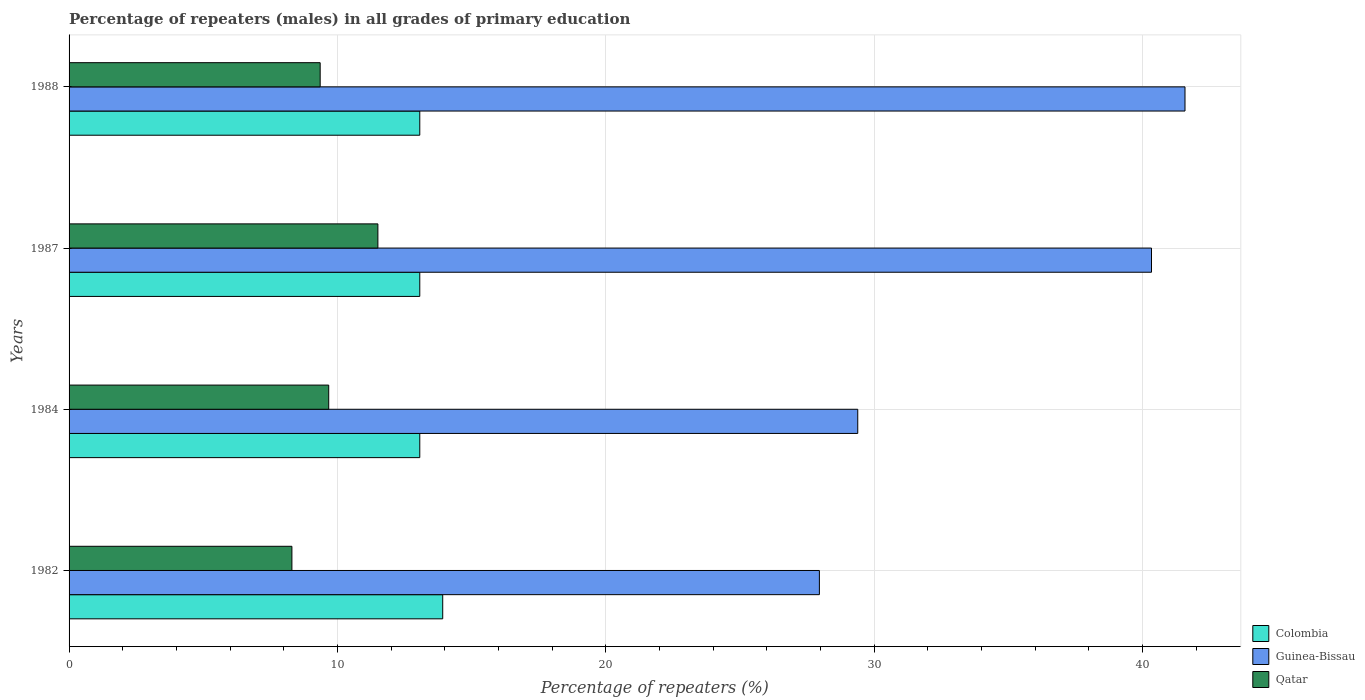What is the label of the 1st group of bars from the top?
Offer a very short reply. 1988. In how many cases, is the number of bars for a given year not equal to the number of legend labels?
Offer a very short reply. 0. What is the percentage of repeaters (males) in Qatar in 1988?
Offer a terse response. 9.36. Across all years, what is the maximum percentage of repeaters (males) in Qatar?
Keep it short and to the point. 11.51. Across all years, what is the minimum percentage of repeaters (males) in Qatar?
Provide a succinct answer. 8.3. In which year was the percentage of repeaters (males) in Colombia maximum?
Provide a short and direct response. 1982. What is the total percentage of repeaters (males) in Colombia in the graph?
Offer a very short reply. 53.13. What is the difference between the percentage of repeaters (males) in Qatar in 1987 and that in 1988?
Your answer should be very brief. 2.15. What is the difference between the percentage of repeaters (males) in Colombia in 1987 and the percentage of repeaters (males) in Qatar in 1988?
Make the answer very short. 3.71. What is the average percentage of repeaters (males) in Guinea-Bissau per year?
Your answer should be compact. 34.81. In the year 1982, what is the difference between the percentage of repeaters (males) in Qatar and percentage of repeaters (males) in Colombia?
Provide a short and direct response. -5.62. What is the ratio of the percentage of repeaters (males) in Colombia in 1984 to that in 1987?
Make the answer very short. 1. Is the difference between the percentage of repeaters (males) in Qatar in 1984 and 1988 greater than the difference between the percentage of repeaters (males) in Colombia in 1984 and 1988?
Ensure brevity in your answer.  Yes. What is the difference between the highest and the second highest percentage of repeaters (males) in Qatar?
Your response must be concise. 1.83. What is the difference between the highest and the lowest percentage of repeaters (males) in Colombia?
Your answer should be very brief. 0.85. In how many years, is the percentage of repeaters (males) in Guinea-Bissau greater than the average percentage of repeaters (males) in Guinea-Bissau taken over all years?
Give a very brief answer. 2. What does the 2nd bar from the top in 1984 represents?
Ensure brevity in your answer.  Guinea-Bissau. What does the 2nd bar from the bottom in 1982 represents?
Your answer should be very brief. Guinea-Bissau. Is it the case that in every year, the sum of the percentage of repeaters (males) in Colombia and percentage of repeaters (males) in Qatar is greater than the percentage of repeaters (males) in Guinea-Bissau?
Keep it short and to the point. No. Are all the bars in the graph horizontal?
Make the answer very short. Yes. What is the difference between two consecutive major ticks on the X-axis?
Provide a succinct answer. 10. Are the values on the major ticks of X-axis written in scientific E-notation?
Give a very brief answer. No. Does the graph contain any zero values?
Your response must be concise. No. How are the legend labels stacked?
Your answer should be very brief. Vertical. What is the title of the graph?
Your answer should be compact. Percentage of repeaters (males) in all grades of primary education. Does "Nigeria" appear as one of the legend labels in the graph?
Ensure brevity in your answer.  No. What is the label or title of the X-axis?
Your answer should be compact. Percentage of repeaters (%). What is the label or title of the Y-axis?
Make the answer very short. Years. What is the Percentage of repeaters (%) in Colombia in 1982?
Keep it short and to the point. 13.92. What is the Percentage of repeaters (%) in Guinea-Bissau in 1982?
Your response must be concise. 27.96. What is the Percentage of repeaters (%) of Qatar in 1982?
Your answer should be compact. 8.3. What is the Percentage of repeaters (%) in Colombia in 1984?
Your response must be concise. 13.07. What is the Percentage of repeaters (%) of Guinea-Bissau in 1984?
Provide a succinct answer. 29.39. What is the Percentage of repeaters (%) of Qatar in 1984?
Ensure brevity in your answer.  9.67. What is the Percentage of repeaters (%) of Colombia in 1987?
Offer a very short reply. 13.07. What is the Percentage of repeaters (%) of Guinea-Bissau in 1987?
Offer a terse response. 40.33. What is the Percentage of repeaters (%) in Qatar in 1987?
Your answer should be very brief. 11.51. What is the Percentage of repeaters (%) of Colombia in 1988?
Provide a short and direct response. 13.07. What is the Percentage of repeaters (%) of Guinea-Bissau in 1988?
Your answer should be very brief. 41.58. What is the Percentage of repeaters (%) in Qatar in 1988?
Provide a short and direct response. 9.36. Across all years, what is the maximum Percentage of repeaters (%) in Colombia?
Your answer should be very brief. 13.92. Across all years, what is the maximum Percentage of repeaters (%) of Guinea-Bissau?
Provide a succinct answer. 41.58. Across all years, what is the maximum Percentage of repeaters (%) in Qatar?
Your answer should be compact. 11.51. Across all years, what is the minimum Percentage of repeaters (%) of Colombia?
Make the answer very short. 13.07. Across all years, what is the minimum Percentage of repeaters (%) of Guinea-Bissau?
Keep it short and to the point. 27.96. Across all years, what is the minimum Percentage of repeaters (%) in Qatar?
Make the answer very short. 8.3. What is the total Percentage of repeaters (%) of Colombia in the graph?
Provide a short and direct response. 53.13. What is the total Percentage of repeaters (%) of Guinea-Bissau in the graph?
Make the answer very short. 139.26. What is the total Percentage of repeaters (%) in Qatar in the graph?
Offer a very short reply. 38.84. What is the difference between the Percentage of repeaters (%) of Colombia in 1982 and that in 1984?
Provide a succinct answer. 0.85. What is the difference between the Percentage of repeaters (%) in Guinea-Bissau in 1982 and that in 1984?
Ensure brevity in your answer.  -1.43. What is the difference between the Percentage of repeaters (%) in Qatar in 1982 and that in 1984?
Your answer should be very brief. -1.37. What is the difference between the Percentage of repeaters (%) of Colombia in 1982 and that in 1987?
Your answer should be very brief. 0.85. What is the difference between the Percentage of repeaters (%) in Guinea-Bissau in 1982 and that in 1987?
Provide a succinct answer. -12.38. What is the difference between the Percentage of repeaters (%) of Qatar in 1982 and that in 1987?
Your answer should be very brief. -3.2. What is the difference between the Percentage of repeaters (%) in Colombia in 1982 and that in 1988?
Keep it short and to the point. 0.85. What is the difference between the Percentage of repeaters (%) of Guinea-Bissau in 1982 and that in 1988?
Ensure brevity in your answer.  -13.62. What is the difference between the Percentage of repeaters (%) of Qatar in 1982 and that in 1988?
Offer a terse response. -1.05. What is the difference between the Percentage of repeaters (%) of Colombia in 1984 and that in 1987?
Make the answer very short. 0. What is the difference between the Percentage of repeaters (%) in Guinea-Bissau in 1984 and that in 1987?
Ensure brevity in your answer.  -10.95. What is the difference between the Percentage of repeaters (%) of Qatar in 1984 and that in 1987?
Offer a very short reply. -1.83. What is the difference between the Percentage of repeaters (%) in Guinea-Bissau in 1984 and that in 1988?
Provide a succinct answer. -12.19. What is the difference between the Percentage of repeaters (%) of Qatar in 1984 and that in 1988?
Make the answer very short. 0.32. What is the difference between the Percentage of repeaters (%) of Guinea-Bissau in 1987 and that in 1988?
Give a very brief answer. -1.25. What is the difference between the Percentage of repeaters (%) of Qatar in 1987 and that in 1988?
Give a very brief answer. 2.15. What is the difference between the Percentage of repeaters (%) of Colombia in 1982 and the Percentage of repeaters (%) of Guinea-Bissau in 1984?
Keep it short and to the point. -15.46. What is the difference between the Percentage of repeaters (%) in Colombia in 1982 and the Percentage of repeaters (%) in Qatar in 1984?
Offer a terse response. 4.25. What is the difference between the Percentage of repeaters (%) of Guinea-Bissau in 1982 and the Percentage of repeaters (%) of Qatar in 1984?
Your answer should be compact. 18.28. What is the difference between the Percentage of repeaters (%) of Colombia in 1982 and the Percentage of repeaters (%) of Guinea-Bissau in 1987?
Provide a succinct answer. -26.41. What is the difference between the Percentage of repeaters (%) in Colombia in 1982 and the Percentage of repeaters (%) in Qatar in 1987?
Your answer should be compact. 2.42. What is the difference between the Percentage of repeaters (%) of Guinea-Bissau in 1982 and the Percentage of repeaters (%) of Qatar in 1987?
Provide a succinct answer. 16.45. What is the difference between the Percentage of repeaters (%) in Colombia in 1982 and the Percentage of repeaters (%) in Guinea-Bissau in 1988?
Give a very brief answer. -27.66. What is the difference between the Percentage of repeaters (%) in Colombia in 1982 and the Percentage of repeaters (%) in Qatar in 1988?
Keep it short and to the point. 4.57. What is the difference between the Percentage of repeaters (%) in Guinea-Bissau in 1982 and the Percentage of repeaters (%) in Qatar in 1988?
Your answer should be compact. 18.6. What is the difference between the Percentage of repeaters (%) of Colombia in 1984 and the Percentage of repeaters (%) of Guinea-Bissau in 1987?
Provide a short and direct response. -27.26. What is the difference between the Percentage of repeaters (%) of Colombia in 1984 and the Percentage of repeaters (%) of Qatar in 1987?
Provide a succinct answer. 1.56. What is the difference between the Percentage of repeaters (%) of Guinea-Bissau in 1984 and the Percentage of repeaters (%) of Qatar in 1987?
Provide a succinct answer. 17.88. What is the difference between the Percentage of repeaters (%) of Colombia in 1984 and the Percentage of repeaters (%) of Guinea-Bissau in 1988?
Make the answer very short. -28.51. What is the difference between the Percentage of repeaters (%) in Colombia in 1984 and the Percentage of repeaters (%) in Qatar in 1988?
Your answer should be compact. 3.71. What is the difference between the Percentage of repeaters (%) in Guinea-Bissau in 1984 and the Percentage of repeaters (%) in Qatar in 1988?
Give a very brief answer. 20.03. What is the difference between the Percentage of repeaters (%) of Colombia in 1987 and the Percentage of repeaters (%) of Guinea-Bissau in 1988?
Provide a succinct answer. -28.51. What is the difference between the Percentage of repeaters (%) in Colombia in 1987 and the Percentage of repeaters (%) in Qatar in 1988?
Keep it short and to the point. 3.71. What is the difference between the Percentage of repeaters (%) in Guinea-Bissau in 1987 and the Percentage of repeaters (%) in Qatar in 1988?
Keep it short and to the point. 30.98. What is the average Percentage of repeaters (%) of Colombia per year?
Your answer should be compact. 13.28. What is the average Percentage of repeaters (%) of Guinea-Bissau per year?
Give a very brief answer. 34.81. What is the average Percentage of repeaters (%) in Qatar per year?
Your response must be concise. 9.71. In the year 1982, what is the difference between the Percentage of repeaters (%) in Colombia and Percentage of repeaters (%) in Guinea-Bissau?
Your answer should be compact. -14.04. In the year 1982, what is the difference between the Percentage of repeaters (%) in Colombia and Percentage of repeaters (%) in Qatar?
Your answer should be very brief. 5.62. In the year 1982, what is the difference between the Percentage of repeaters (%) in Guinea-Bissau and Percentage of repeaters (%) in Qatar?
Your answer should be compact. 19.65. In the year 1984, what is the difference between the Percentage of repeaters (%) of Colombia and Percentage of repeaters (%) of Guinea-Bissau?
Your answer should be very brief. -16.32. In the year 1984, what is the difference between the Percentage of repeaters (%) of Colombia and Percentage of repeaters (%) of Qatar?
Give a very brief answer. 3.39. In the year 1984, what is the difference between the Percentage of repeaters (%) of Guinea-Bissau and Percentage of repeaters (%) of Qatar?
Give a very brief answer. 19.71. In the year 1987, what is the difference between the Percentage of repeaters (%) in Colombia and Percentage of repeaters (%) in Guinea-Bissau?
Ensure brevity in your answer.  -27.26. In the year 1987, what is the difference between the Percentage of repeaters (%) in Colombia and Percentage of repeaters (%) in Qatar?
Your answer should be very brief. 1.56. In the year 1987, what is the difference between the Percentage of repeaters (%) in Guinea-Bissau and Percentage of repeaters (%) in Qatar?
Your response must be concise. 28.83. In the year 1988, what is the difference between the Percentage of repeaters (%) of Colombia and Percentage of repeaters (%) of Guinea-Bissau?
Give a very brief answer. -28.51. In the year 1988, what is the difference between the Percentage of repeaters (%) of Colombia and Percentage of repeaters (%) of Qatar?
Provide a short and direct response. 3.71. In the year 1988, what is the difference between the Percentage of repeaters (%) of Guinea-Bissau and Percentage of repeaters (%) of Qatar?
Ensure brevity in your answer.  32.22. What is the ratio of the Percentage of repeaters (%) of Colombia in 1982 to that in 1984?
Offer a very short reply. 1.07. What is the ratio of the Percentage of repeaters (%) of Guinea-Bissau in 1982 to that in 1984?
Make the answer very short. 0.95. What is the ratio of the Percentage of repeaters (%) in Qatar in 1982 to that in 1984?
Your answer should be very brief. 0.86. What is the ratio of the Percentage of repeaters (%) in Colombia in 1982 to that in 1987?
Provide a succinct answer. 1.07. What is the ratio of the Percentage of repeaters (%) in Guinea-Bissau in 1982 to that in 1987?
Offer a terse response. 0.69. What is the ratio of the Percentage of repeaters (%) in Qatar in 1982 to that in 1987?
Your answer should be compact. 0.72. What is the ratio of the Percentage of repeaters (%) in Colombia in 1982 to that in 1988?
Provide a short and direct response. 1.07. What is the ratio of the Percentage of repeaters (%) in Guinea-Bissau in 1982 to that in 1988?
Your answer should be very brief. 0.67. What is the ratio of the Percentage of repeaters (%) in Qatar in 1982 to that in 1988?
Provide a short and direct response. 0.89. What is the ratio of the Percentage of repeaters (%) in Colombia in 1984 to that in 1987?
Ensure brevity in your answer.  1. What is the ratio of the Percentage of repeaters (%) in Guinea-Bissau in 1984 to that in 1987?
Your response must be concise. 0.73. What is the ratio of the Percentage of repeaters (%) in Qatar in 1984 to that in 1987?
Keep it short and to the point. 0.84. What is the ratio of the Percentage of repeaters (%) of Guinea-Bissau in 1984 to that in 1988?
Keep it short and to the point. 0.71. What is the ratio of the Percentage of repeaters (%) in Qatar in 1984 to that in 1988?
Keep it short and to the point. 1.03. What is the ratio of the Percentage of repeaters (%) of Colombia in 1987 to that in 1988?
Provide a succinct answer. 1. What is the ratio of the Percentage of repeaters (%) of Guinea-Bissau in 1987 to that in 1988?
Make the answer very short. 0.97. What is the ratio of the Percentage of repeaters (%) of Qatar in 1987 to that in 1988?
Offer a terse response. 1.23. What is the difference between the highest and the second highest Percentage of repeaters (%) in Colombia?
Provide a short and direct response. 0.85. What is the difference between the highest and the second highest Percentage of repeaters (%) in Guinea-Bissau?
Your response must be concise. 1.25. What is the difference between the highest and the second highest Percentage of repeaters (%) of Qatar?
Offer a terse response. 1.83. What is the difference between the highest and the lowest Percentage of repeaters (%) of Colombia?
Ensure brevity in your answer.  0.85. What is the difference between the highest and the lowest Percentage of repeaters (%) in Guinea-Bissau?
Your answer should be compact. 13.62. What is the difference between the highest and the lowest Percentage of repeaters (%) in Qatar?
Provide a succinct answer. 3.2. 